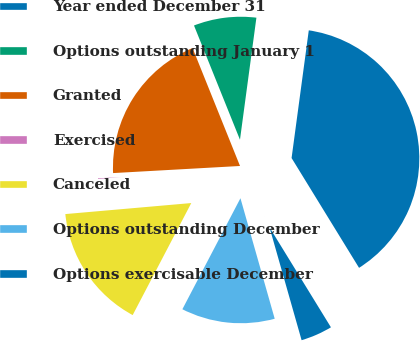<chart> <loc_0><loc_0><loc_500><loc_500><pie_chart><fcel>Year ended December 31<fcel>Options outstanding January 1<fcel>Granted<fcel>Exercised<fcel>Canceled<fcel>Options outstanding December<fcel>Options exercisable December<nl><fcel>39.1%<fcel>8.22%<fcel>19.8%<fcel>0.5%<fcel>15.94%<fcel>12.08%<fcel>4.36%<nl></chart> 